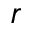Convert formula to latex. <formula><loc_0><loc_0><loc_500><loc_500>r</formula> 